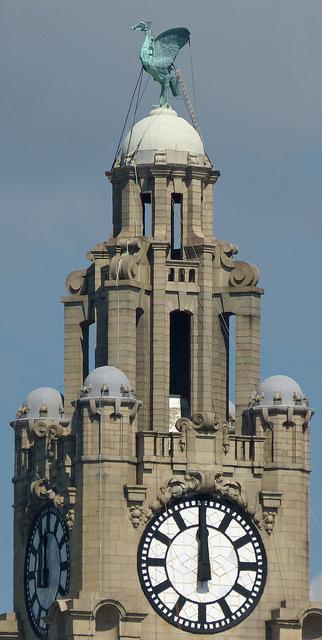What is the blue object on the top of the building?
Short answer required. Bird. Which house appears to have a window box?
Write a very short answer. None. What time is it?
Quick response, please. 12:00. What color is the clock?
Give a very brief answer. White. Is this the clock tower from "back to the future"?
Quick response, please. No. Is the clock showing the right time?
Be succinct. Yes. How many Roman numerals are on the clock?
Give a very brief answer. 12. What bird is represented on the building?
Concise answer only. Peacock. 